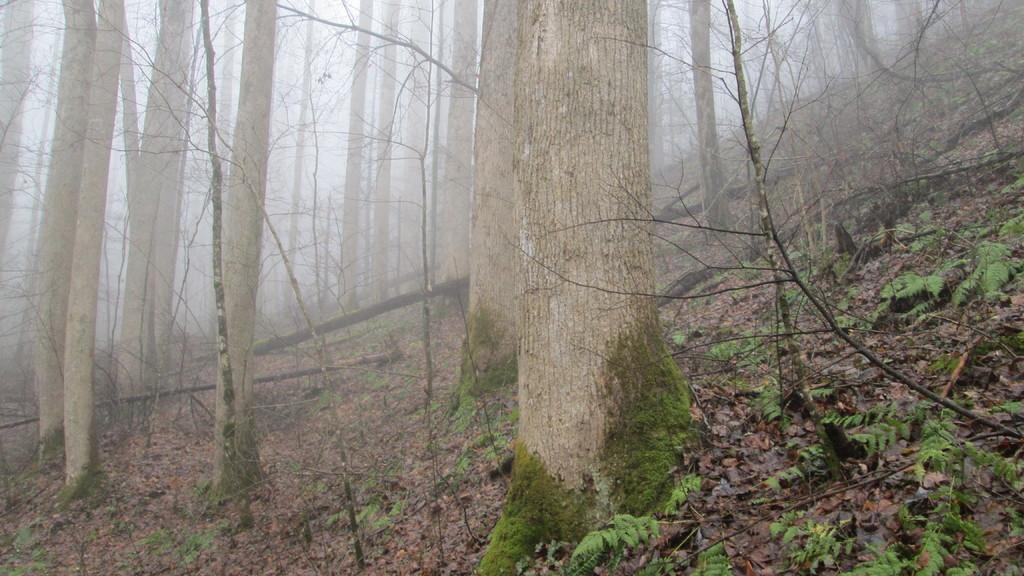Please provide a concise description of this image. In this picture we can see the trees and fog. At the bottom of the image we can see the dry leaves and twigs. 